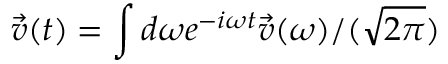<formula> <loc_0><loc_0><loc_500><loc_500>\vec { v } ( t ) = \int d \omega e ^ { - i \omega t } \vec { v } ( \omega ) / ( \sqrt { 2 \pi } )</formula> 